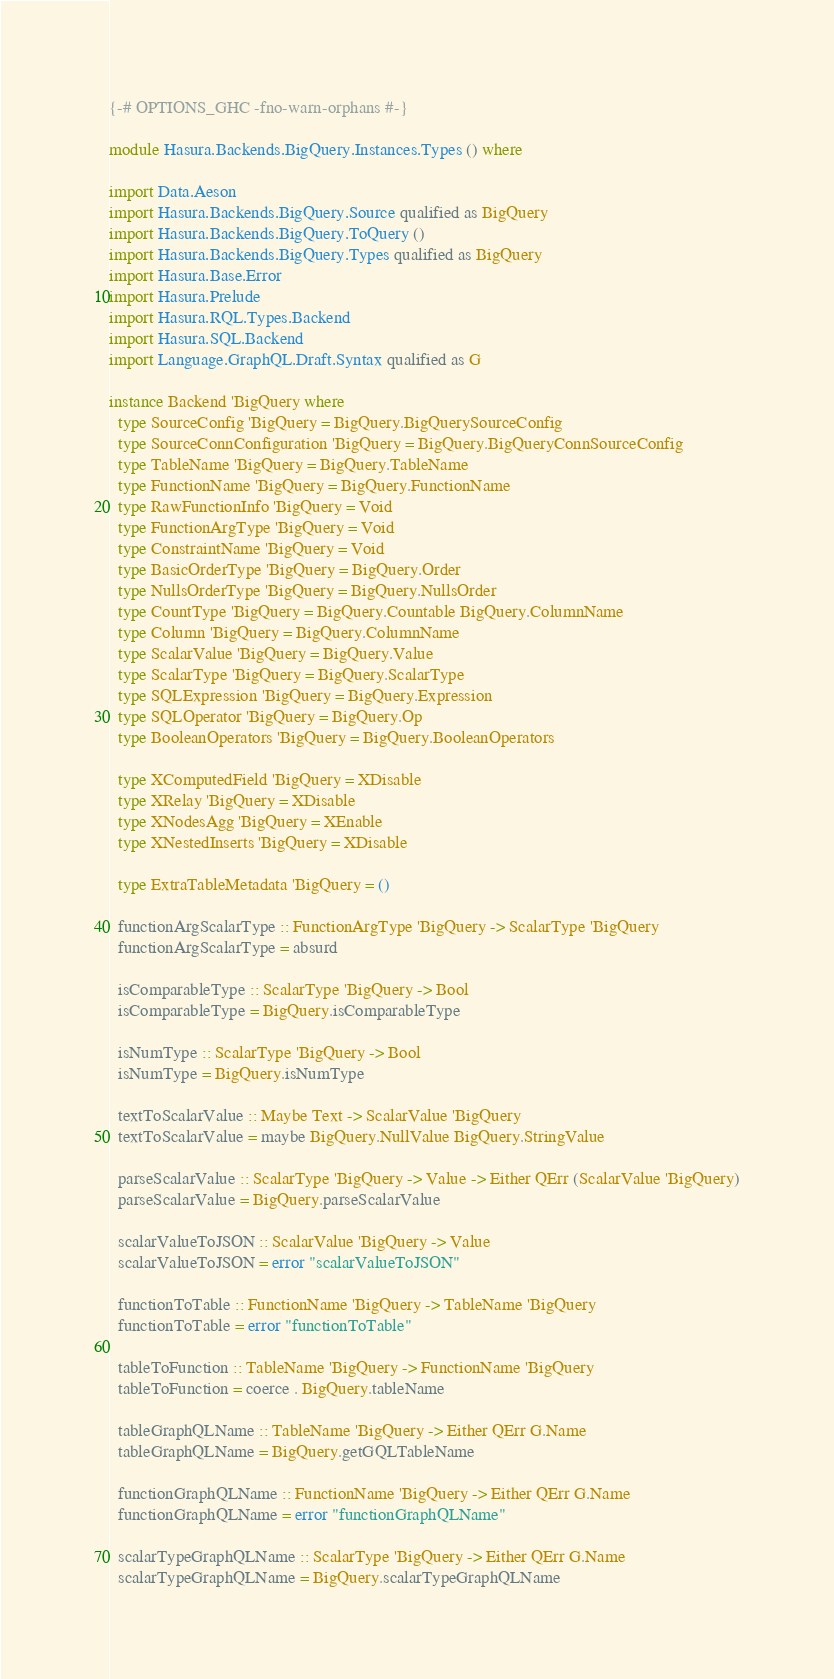<code> <loc_0><loc_0><loc_500><loc_500><_Haskell_>{-# OPTIONS_GHC -fno-warn-orphans #-}

module Hasura.Backends.BigQuery.Instances.Types () where

import Data.Aeson
import Hasura.Backends.BigQuery.Source qualified as BigQuery
import Hasura.Backends.BigQuery.ToQuery ()
import Hasura.Backends.BigQuery.Types qualified as BigQuery
import Hasura.Base.Error
import Hasura.Prelude
import Hasura.RQL.Types.Backend
import Hasura.SQL.Backend
import Language.GraphQL.Draft.Syntax qualified as G

instance Backend 'BigQuery where
  type SourceConfig 'BigQuery = BigQuery.BigQuerySourceConfig
  type SourceConnConfiguration 'BigQuery = BigQuery.BigQueryConnSourceConfig
  type TableName 'BigQuery = BigQuery.TableName
  type FunctionName 'BigQuery = BigQuery.FunctionName
  type RawFunctionInfo 'BigQuery = Void
  type FunctionArgType 'BigQuery = Void
  type ConstraintName 'BigQuery = Void
  type BasicOrderType 'BigQuery = BigQuery.Order
  type NullsOrderType 'BigQuery = BigQuery.NullsOrder
  type CountType 'BigQuery = BigQuery.Countable BigQuery.ColumnName
  type Column 'BigQuery = BigQuery.ColumnName
  type ScalarValue 'BigQuery = BigQuery.Value
  type ScalarType 'BigQuery = BigQuery.ScalarType
  type SQLExpression 'BigQuery = BigQuery.Expression
  type SQLOperator 'BigQuery = BigQuery.Op
  type BooleanOperators 'BigQuery = BigQuery.BooleanOperators

  type XComputedField 'BigQuery = XDisable
  type XRelay 'BigQuery = XDisable
  type XNodesAgg 'BigQuery = XEnable
  type XNestedInserts 'BigQuery = XDisable

  type ExtraTableMetadata 'BigQuery = ()

  functionArgScalarType :: FunctionArgType 'BigQuery -> ScalarType 'BigQuery
  functionArgScalarType = absurd

  isComparableType :: ScalarType 'BigQuery -> Bool
  isComparableType = BigQuery.isComparableType

  isNumType :: ScalarType 'BigQuery -> Bool
  isNumType = BigQuery.isNumType

  textToScalarValue :: Maybe Text -> ScalarValue 'BigQuery
  textToScalarValue = maybe BigQuery.NullValue BigQuery.StringValue

  parseScalarValue :: ScalarType 'BigQuery -> Value -> Either QErr (ScalarValue 'BigQuery)
  parseScalarValue = BigQuery.parseScalarValue

  scalarValueToJSON :: ScalarValue 'BigQuery -> Value
  scalarValueToJSON = error "scalarValueToJSON"

  functionToTable :: FunctionName 'BigQuery -> TableName 'BigQuery
  functionToTable = error "functionToTable"

  tableToFunction :: TableName 'BigQuery -> FunctionName 'BigQuery
  tableToFunction = coerce . BigQuery.tableName

  tableGraphQLName :: TableName 'BigQuery -> Either QErr G.Name
  tableGraphQLName = BigQuery.getGQLTableName

  functionGraphQLName :: FunctionName 'BigQuery -> Either QErr G.Name
  functionGraphQLName = error "functionGraphQLName"

  scalarTypeGraphQLName :: ScalarType 'BigQuery -> Either QErr G.Name
  scalarTypeGraphQLName = BigQuery.scalarTypeGraphQLName
</code> 